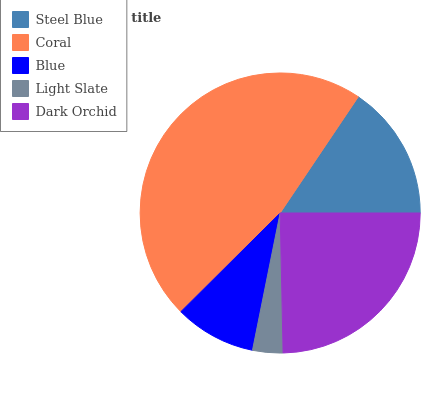Is Light Slate the minimum?
Answer yes or no. Yes. Is Coral the maximum?
Answer yes or no. Yes. Is Blue the minimum?
Answer yes or no. No. Is Blue the maximum?
Answer yes or no. No. Is Coral greater than Blue?
Answer yes or no. Yes. Is Blue less than Coral?
Answer yes or no. Yes. Is Blue greater than Coral?
Answer yes or no. No. Is Coral less than Blue?
Answer yes or no. No. Is Steel Blue the high median?
Answer yes or no. Yes. Is Steel Blue the low median?
Answer yes or no. Yes. Is Blue the high median?
Answer yes or no. No. Is Coral the low median?
Answer yes or no. No. 